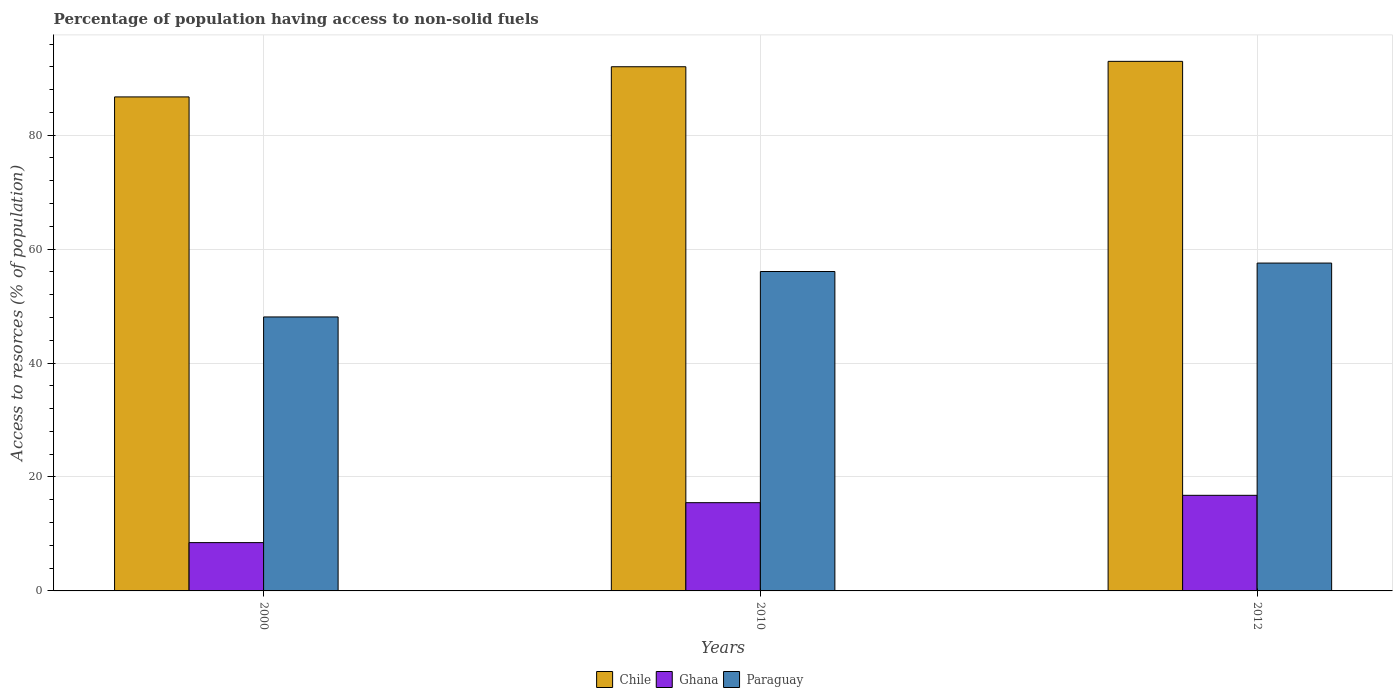How many different coloured bars are there?
Ensure brevity in your answer.  3. How many groups of bars are there?
Make the answer very short. 3. Are the number of bars per tick equal to the number of legend labels?
Give a very brief answer. Yes. Are the number of bars on each tick of the X-axis equal?
Make the answer very short. Yes. How many bars are there on the 2nd tick from the left?
Keep it short and to the point. 3. How many bars are there on the 2nd tick from the right?
Make the answer very short. 3. What is the label of the 3rd group of bars from the left?
Your response must be concise. 2012. What is the percentage of population having access to non-solid fuels in Chile in 2010?
Provide a short and direct response. 92.02. Across all years, what is the maximum percentage of population having access to non-solid fuels in Ghana?
Make the answer very short. 16.78. Across all years, what is the minimum percentage of population having access to non-solid fuels in Paraguay?
Give a very brief answer. 48.09. What is the total percentage of population having access to non-solid fuels in Ghana in the graph?
Keep it short and to the point. 40.75. What is the difference between the percentage of population having access to non-solid fuels in Chile in 2000 and that in 2012?
Keep it short and to the point. -6.24. What is the difference between the percentage of population having access to non-solid fuels in Paraguay in 2010 and the percentage of population having access to non-solid fuels in Chile in 2012?
Keep it short and to the point. -36.89. What is the average percentage of population having access to non-solid fuels in Ghana per year?
Offer a very short reply. 13.58. In the year 2000, what is the difference between the percentage of population having access to non-solid fuels in Chile and percentage of population having access to non-solid fuels in Paraguay?
Provide a short and direct response. 38.63. In how many years, is the percentage of population having access to non-solid fuels in Chile greater than 60 %?
Ensure brevity in your answer.  3. What is the ratio of the percentage of population having access to non-solid fuels in Paraguay in 2010 to that in 2012?
Provide a short and direct response. 0.97. Is the percentage of population having access to non-solid fuels in Chile in 2010 less than that in 2012?
Make the answer very short. Yes. What is the difference between the highest and the second highest percentage of population having access to non-solid fuels in Chile?
Give a very brief answer. 0.94. What is the difference between the highest and the lowest percentage of population having access to non-solid fuels in Ghana?
Give a very brief answer. 8.3. In how many years, is the percentage of population having access to non-solid fuels in Paraguay greater than the average percentage of population having access to non-solid fuels in Paraguay taken over all years?
Offer a terse response. 2. What does the 1st bar from the left in 2000 represents?
Offer a very short reply. Chile. What does the 3rd bar from the right in 2000 represents?
Your answer should be very brief. Chile. Is it the case that in every year, the sum of the percentage of population having access to non-solid fuels in Ghana and percentage of population having access to non-solid fuels in Chile is greater than the percentage of population having access to non-solid fuels in Paraguay?
Provide a succinct answer. Yes. How many years are there in the graph?
Give a very brief answer. 3. Does the graph contain grids?
Provide a short and direct response. Yes. Where does the legend appear in the graph?
Provide a succinct answer. Bottom center. How many legend labels are there?
Offer a very short reply. 3. What is the title of the graph?
Provide a short and direct response. Percentage of population having access to non-solid fuels. Does "Turkey" appear as one of the legend labels in the graph?
Ensure brevity in your answer.  No. What is the label or title of the X-axis?
Give a very brief answer. Years. What is the label or title of the Y-axis?
Ensure brevity in your answer.  Access to resorces (% of population). What is the Access to resorces (% of population) in Chile in 2000?
Your answer should be very brief. 86.72. What is the Access to resorces (% of population) of Ghana in 2000?
Offer a terse response. 8.48. What is the Access to resorces (% of population) in Paraguay in 2000?
Your response must be concise. 48.09. What is the Access to resorces (% of population) in Chile in 2010?
Offer a terse response. 92.02. What is the Access to resorces (% of population) in Ghana in 2010?
Offer a terse response. 15.49. What is the Access to resorces (% of population) in Paraguay in 2010?
Give a very brief answer. 56.07. What is the Access to resorces (% of population) of Chile in 2012?
Offer a terse response. 92.96. What is the Access to resorces (% of population) of Ghana in 2012?
Keep it short and to the point. 16.78. What is the Access to resorces (% of population) of Paraguay in 2012?
Ensure brevity in your answer.  57.55. Across all years, what is the maximum Access to resorces (% of population) of Chile?
Make the answer very short. 92.96. Across all years, what is the maximum Access to resorces (% of population) in Ghana?
Provide a succinct answer. 16.78. Across all years, what is the maximum Access to resorces (% of population) in Paraguay?
Provide a short and direct response. 57.55. Across all years, what is the minimum Access to resorces (% of population) in Chile?
Provide a short and direct response. 86.72. Across all years, what is the minimum Access to resorces (% of population) in Ghana?
Provide a succinct answer. 8.48. Across all years, what is the minimum Access to resorces (% of population) of Paraguay?
Provide a short and direct response. 48.09. What is the total Access to resorces (% of population) in Chile in the graph?
Provide a short and direct response. 271.7. What is the total Access to resorces (% of population) of Ghana in the graph?
Provide a short and direct response. 40.75. What is the total Access to resorces (% of population) of Paraguay in the graph?
Provide a short and direct response. 161.71. What is the difference between the Access to resorces (% of population) in Chile in 2000 and that in 2010?
Offer a terse response. -5.3. What is the difference between the Access to resorces (% of population) in Ghana in 2000 and that in 2010?
Your response must be concise. -7.01. What is the difference between the Access to resorces (% of population) in Paraguay in 2000 and that in 2010?
Give a very brief answer. -7.98. What is the difference between the Access to resorces (% of population) of Chile in 2000 and that in 2012?
Your answer should be very brief. -6.24. What is the difference between the Access to resorces (% of population) of Ghana in 2000 and that in 2012?
Give a very brief answer. -8.3. What is the difference between the Access to resorces (% of population) of Paraguay in 2000 and that in 2012?
Give a very brief answer. -9.46. What is the difference between the Access to resorces (% of population) of Chile in 2010 and that in 2012?
Keep it short and to the point. -0.94. What is the difference between the Access to resorces (% of population) of Ghana in 2010 and that in 2012?
Offer a very short reply. -1.29. What is the difference between the Access to resorces (% of population) of Paraguay in 2010 and that in 2012?
Offer a very short reply. -1.48. What is the difference between the Access to resorces (% of population) in Chile in 2000 and the Access to resorces (% of population) in Ghana in 2010?
Your response must be concise. 71.23. What is the difference between the Access to resorces (% of population) in Chile in 2000 and the Access to resorces (% of population) in Paraguay in 2010?
Your response must be concise. 30.65. What is the difference between the Access to resorces (% of population) of Ghana in 2000 and the Access to resorces (% of population) of Paraguay in 2010?
Your answer should be very brief. -47.59. What is the difference between the Access to resorces (% of population) of Chile in 2000 and the Access to resorces (% of population) of Ghana in 2012?
Your answer should be very brief. 69.94. What is the difference between the Access to resorces (% of population) of Chile in 2000 and the Access to resorces (% of population) of Paraguay in 2012?
Ensure brevity in your answer.  29.17. What is the difference between the Access to resorces (% of population) of Ghana in 2000 and the Access to resorces (% of population) of Paraguay in 2012?
Keep it short and to the point. -49.07. What is the difference between the Access to resorces (% of population) of Chile in 2010 and the Access to resorces (% of population) of Ghana in 2012?
Offer a terse response. 75.24. What is the difference between the Access to resorces (% of population) in Chile in 2010 and the Access to resorces (% of population) in Paraguay in 2012?
Provide a short and direct response. 34.46. What is the difference between the Access to resorces (% of population) of Ghana in 2010 and the Access to resorces (% of population) of Paraguay in 2012?
Make the answer very short. -42.06. What is the average Access to resorces (% of population) in Chile per year?
Your response must be concise. 90.57. What is the average Access to resorces (% of population) in Ghana per year?
Keep it short and to the point. 13.58. What is the average Access to resorces (% of population) in Paraguay per year?
Give a very brief answer. 53.9. In the year 2000, what is the difference between the Access to resorces (% of population) in Chile and Access to resorces (% of population) in Ghana?
Provide a short and direct response. 78.24. In the year 2000, what is the difference between the Access to resorces (% of population) of Chile and Access to resorces (% of population) of Paraguay?
Provide a succinct answer. 38.63. In the year 2000, what is the difference between the Access to resorces (% of population) in Ghana and Access to resorces (% of population) in Paraguay?
Your response must be concise. -39.61. In the year 2010, what is the difference between the Access to resorces (% of population) of Chile and Access to resorces (% of population) of Ghana?
Provide a short and direct response. 76.53. In the year 2010, what is the difference between the Access to resorces (% of population) of Chile and Access to resorces (% of population) of Paraguay?
Offer a terse response. 35.95. In the year 2010, what is the difference between the Access to resorces (% of population) in Ghana and Access to resorces (% of population) in Paraguay?
Give a very brief answer. -40.58. In the year 2012, what is the difference between the Access to resorces (% of population) of Chile and Access to resorces (% of population) of Ghana?
Provide a succinct answer. 76.18. In the year 2012, what is the difference between the Access to resorces (% of population) in Chile and Access to resorces (% of population) in Paraguay?
Your answer should be compact. 35.41. In the year 2012, what is the difference between the Access to resorces (% of population) in Ghana and Access to resorces (% of population) in Paraguay?
Ensure brevity in your answer.  -40.77. What is the ratio of the Access to resorces (% of population) of Chile in 2000 to that in 2010?
Give a very brief answer. 0.94. What is the ratio of the Access to resorces (% of population) in Ghana in 2000 to that in 2010?
Offer a very short reply. 0.55. What is the ratio of the Access to resorces (% of population) in Paraguay in 2000 to that in 2010?
Give a very brief answer. 0.86. What is the ratio of the Access to resorces (% of population) in Chile in 2000 to that in 2012?
Your answer should be compact. 0.93. What is the ratio of the Access to resorces (% of population) of Ghana in 2000 to that in 2012?
Your response must be concise. 0.51. What is the ratio of the Access to resorces (% of population) of Paraguay in 2000 to that in 2012?
Give a very brief answer. 0.84. What is the ratio of the Access to resorces (% of population) of Chile in 2010 to that in 2012?
Your response must be concise. 0.99. What is the ratio of the Access to resorces (% of population) in Ghana in 2010 to that in 2012?
Offer a terse response. 0.92. What is the ratio of the Access to resorces (% of population) in Paraguay in 2010 to that in 2012?
Provide a short and direct response. 0.97. What is the difference between the highest and the second highest Access to resorces (% of population) in Chile?
Your response must be concise. 0.94. What is the difference between the highest and the second highest Access to resorces (% of population) in Ghana?
Your answer should be compact. 1.29. What is the difference between the highest and the second highest Access to resorces (% of population) of Paraguay?
Give a very brief answer. 1.48. What is the difference between the highest and the lowest Access to resorces (% of population) of Chile?
Offer a very short reply. 6.24. What is the difference between the highest and the lowest Access to resorces (% of population) of Ghana?
Provide a succinct answer. 8.3. What is the difference between the highest and the lowest Access to resorces (% of population) of Paraguay?
Give a very brief answer. 9.46. 